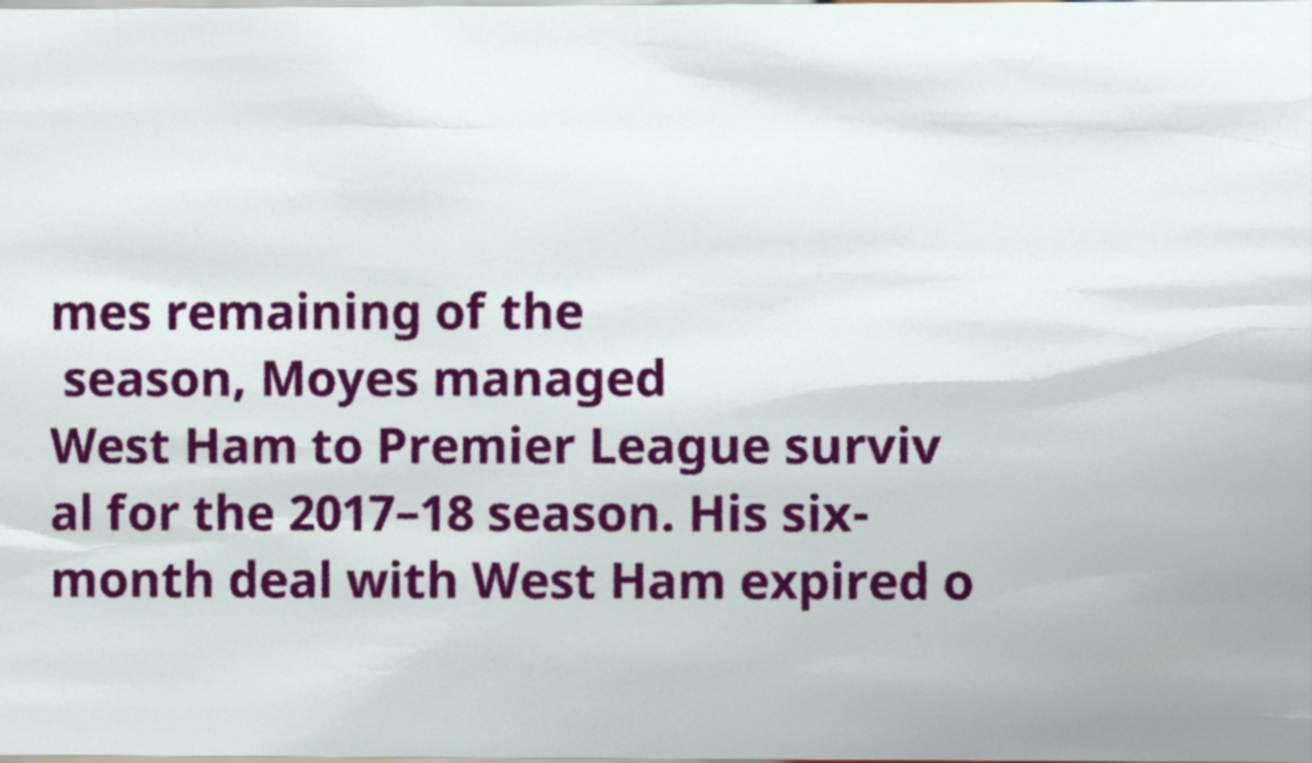Can you read and provide the text displayed in the image?This photo seems to have some interesting text. Can you extract and type it out for me? mes remaining of the season, Moyes managed West Ham to Premier League surviv al for the 2017–18 season. His six- month deal with West Ham expired o 